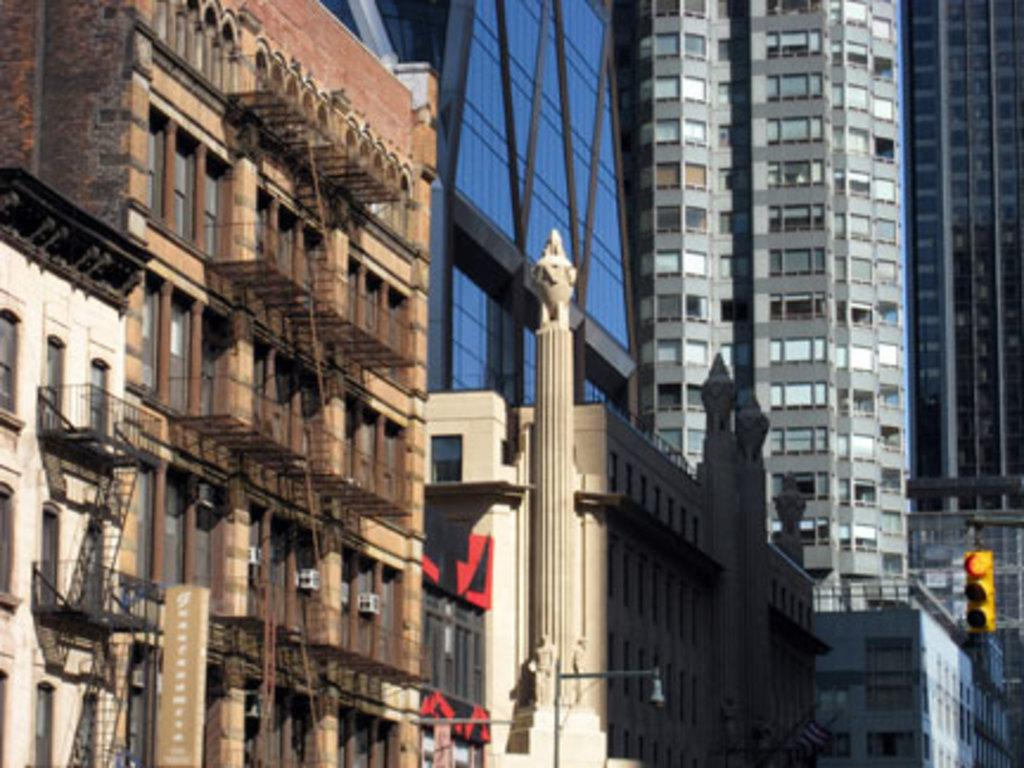What type of structures are present in the image? The image contains buildings and skyscrapers. What feature do the buildings and skyscrapers have? They have windows. Can you describe a specific architectural element in the image? There is a pillar in the middle of the image. How many chickens are perched on the windows of the buildings in the image? There are no chickens present in the image; it features buildings and skyscrapers with windows. What type of knowledge can be gained from the image? The image provides visual information about buildings, skyscrapers, and a pillar, but it does not convey any specific knowledge or teach any lessons. 